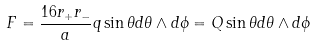<formula> <loc_0><loc_0><loc_500><loc_500>F = \frac { 1 6 r _ { + } r _ { - } } { a } q \sin \theta d \theta \wedge d \phi = Q \sin \theta d \theta \wedge d \phi</formula> 